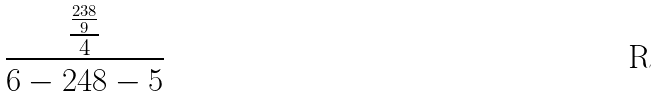<formula> <loc_0><loc_0><loc_500><loc_500>\frac { \frac { \frac { 2 3 8 } { 9 } } { 4 } } { 6 - 2 4 8 - 5 }</formula> 